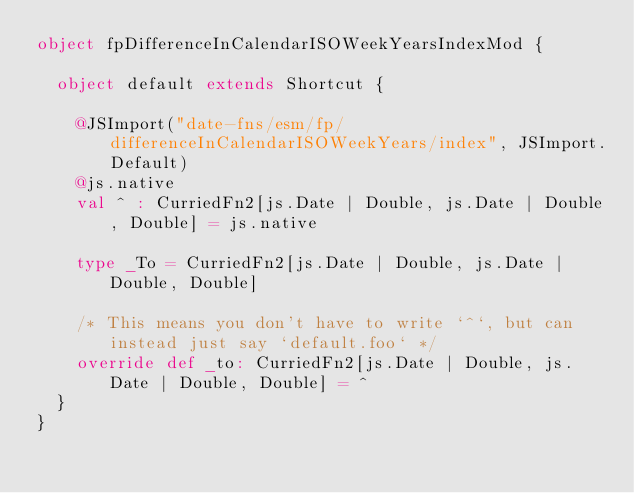<code> <loc_0><loc_0><loc_500><loc_500><_Scala_>object fpDifferenceInCalendarISOWeekYearsIndexMod {
  
  object default extends Shortcut {
    
    @JSImport("date-fns/esm/fp/differenceInCalendarISOWeekYears/index", JSImport.Default)
    @js.native
    val ^ : CurriedFn2[js.Date | Double, js.Date | Double, Double] = js.native
    
    type _To = CurriedFn2[js.Date | Double, js.Date | Double, Double]
    
    /* This means you don't have to write `^`, but can instead just say `default.foo` */
    override def _to: CurriedFn2[js.Date | Double, js.Date | Double, Double] = ^
  }
}
</code> 